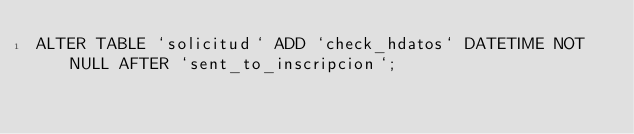<code> <loc_0><loc_0><loc_500><loc_500><_SQL_>ALTER TABLE `solicitud` ADD `check_hdatos` DATETIME NOT NULL AFTER `sent_to_inscripcion`;</code> 